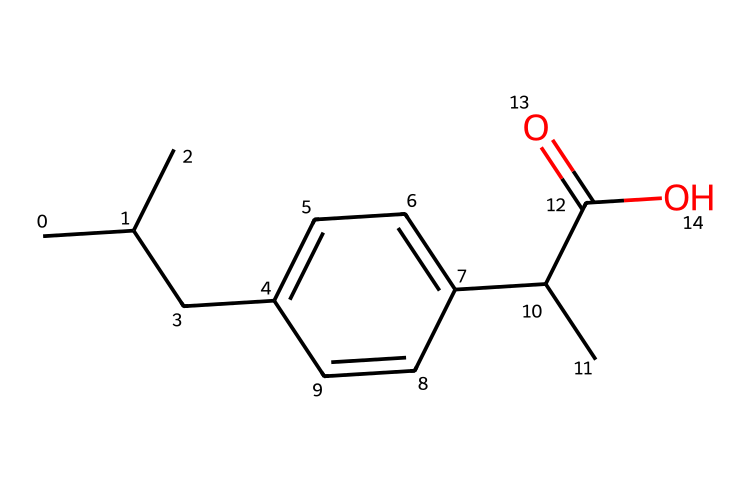what is the molecular formula of this compound? The SMILES notation describes the structure of the compound, which includes the carbon (C), hydrogen (H), and oxygen (O) atoms. Counting the atoms from the SMILES, there are 13 carbon atoms, 18 hydrogen atoms, and 2 oxygen atoms. The molecular formula is therefore C13H18O2.
Answer: C13H18O2 how many rings are present in this chemical structure? By analyzing the structure represented by the SMILES, we notice that there is one cyclic component indicated by the ‘C1’ in the notation, which signifies a ring. Therefore, there is one ring in this chemical structure.
Answer: 1 what type of functional groups are present in this structure? The SMILES indicates the presence of a carboxylic acid functional group seen in the ‘C(=O)O’ part, as well as an aromatic ring denoted by ‘C1=CC’. Thus, the functional groups present are carboxylic acid and aromatic.
Answer: carboxylic acid, aromatic what is the primary use of this drug? Ibuprofen is primarily used as a nonsteroidal anti-inflammatory drug (NSAID) that helps relieve pain and reduce inflammation. It is commonly used for managing pain after surgeries, such as dental procedures.
Answer: pain relief how many double bonds are in the chemical structure? In the SMILES representation, double bonds are indicated by the ‘=’ symbol. There are two double bonds in the structure: one in the aromatic ring and one in the carboxylic acid group. Therefore, the total count of double bonds is two.
Answer: 2 which properties make ibuprofen effective for managing post-surgical pain? Ibuprofen is effective due to its anti-inflammatory properties and ability to inhibit the production of prostaglandins, which are compounds involved in inflammation and pain signaling. This dual action aids in pain management after surgical procedures.
Answer: anti-inflammatory, pain inhibition what is the relationship between the structure and the function of ibuprofen? The structure of ibuprofen allows it to interact with and inhibit cyclooxygenase enzymes (COX-1 and COX-2), which play a crucial role in synthesizing prostaglandins, leading to reduced pain and inflammation. The specific arrangement of the atoms contributes to this inhibition effect.
Answer: inhibits COX enzymes 